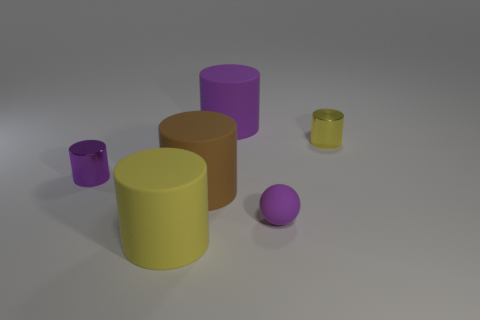Subtract all large brown rubber cylinders. How many cylinders are left? 4 Add 2 large gray metal objects. How many objects exist? 8 Subtract 3 cylinders. How many cylinders are left? 2 Subtract all brown cylinders. How many cylinders are left? 4 Subtract all purple cylinders. Subtract all cyan spheres. How many cylinders are left? 3 Subtract all cylinders. How many objects are left? 1 Subtract all small shiny cylinders. Subtract all big brown matte objects. How many objects are left? 3 Add 3 purple matte things. How many purple matte things are left? 5 Add 2 metal objects. How many metal objects exist? 4 Subtract 0 purple cubes. How many objects are left? 6 